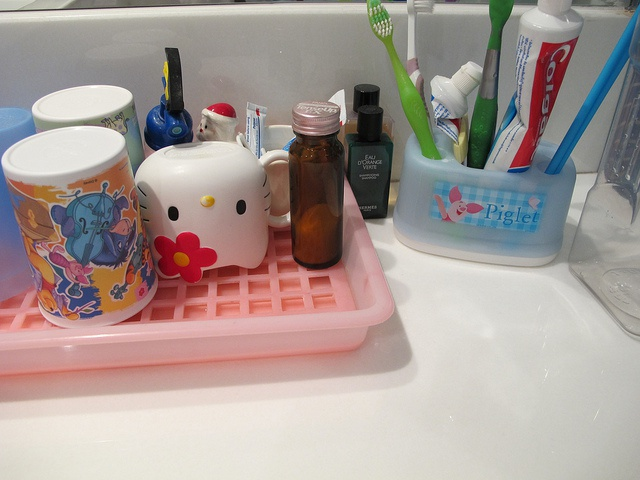Describe the objects in this image and their specific colors. I can see cup in lightgray, brown, and gray tones, cup in lightgray, darkgray, gray, and brown tones, bottle in lightgray, darkgray, gray, and blue tones, bottle in lightgray, black, maroon, gray, and darkgray tones, and cup in lightgray, gray, and darkgray tones in this image. 